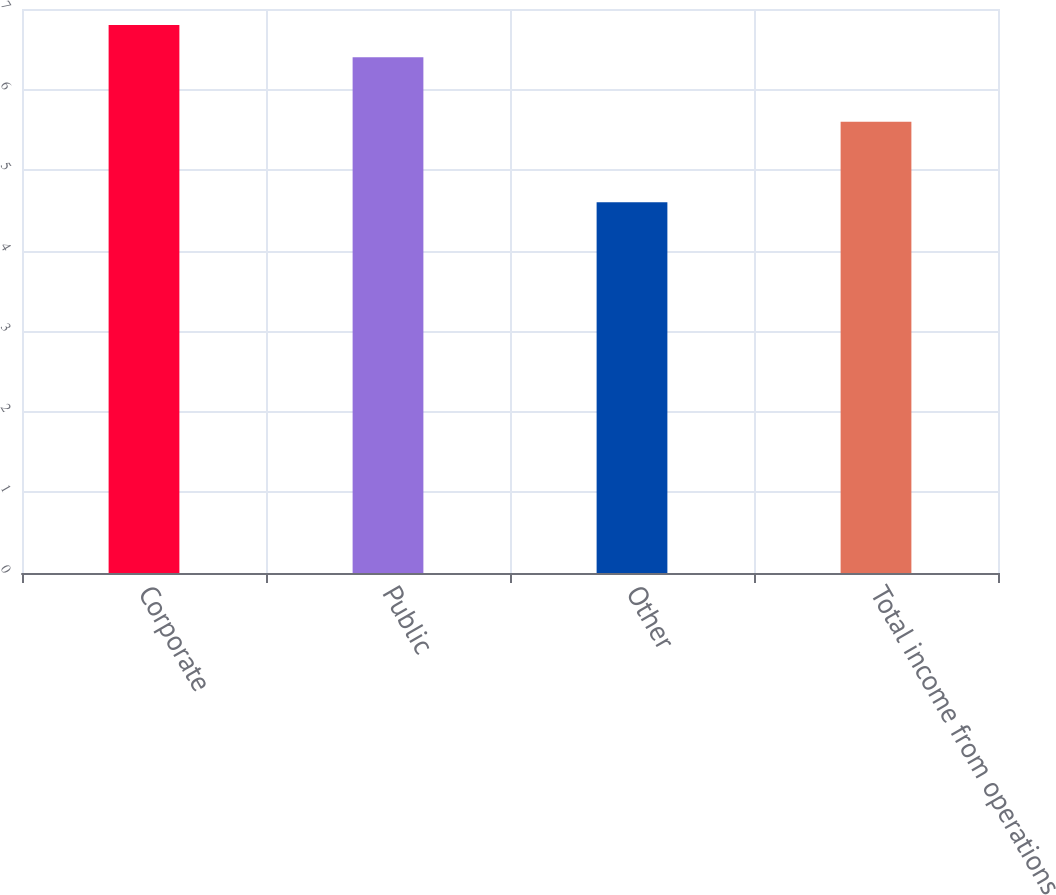Convert chart. <chart><loc_0><loc_0><loc_500><loc_500><bar_chart><fcel>Corporate<fcel>Public<fcel>Other<fcel>Total income from operations<nl><fcel>6.8<fcel>6.4<fcel>4.6<fcel>5.6<nl></chart> 